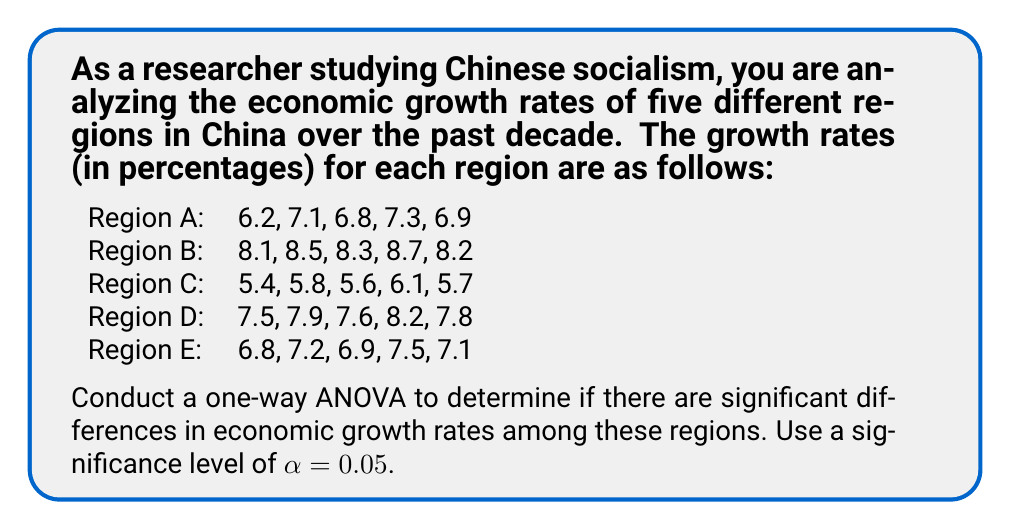Can you answer this question? To conduct a one-way ANOVA, we'll follow these steps:

1. Calculate the sum of squares between groups (SSB), sum of squares within groups (SSW), and total sum of squares (SST).
2. Calculate the degrees of freedom for between groups (dfB) and within groups (dfW).
3. Compute the mean squares between groups (MSB) and within groups (MSW).
4. Calculate the F-statistic.
5. Determine the critical F-value and compare it with our calculated F-statistic.

Step 1: Calculate sums of squares

First, let's calculate the grand mean:
$$ \bar{X} = \frac{6.2 + 7.1 + ... + 7.5 + 7.1}{25} = 7.152 $$

Now, we can calculate SSB, SSW, and SST:

SSB = $\sum_{i=1}^k n_i(\bar{X_i} - \bar{X})^2$
SSW = $\sum_{i=1}^k \sum_{j=1}^{n_i} (X_{ij} - \bar{X_i})^2$
SST = $\sum_{i=1}^k \sum_{j=1}^{n_i} (X_{ij} - \bar{X})^2$

After calculations:
SSB = 30.4416
SSW = 1.616
SST = 32.0576

Step 2: Calculate degrees of freedom

dfB = k - 1 = 5 - 1 = 4 (k is the number of groups)
dfW = N - k = 25 - 5 = 20 (N is the total number of observations)

Step 3: Compute mean squares

MSB = SSB / dfB = 30.4416 / 4 = 7.6104
MSW = SSW / dfW = 1.616 / 20 = 0.0808

Step 4: Calculate F-statistic

F = MSB / MSW = 7.6104 / 0.0808 = 94.1881

Step 5: Determine critical F-value and compare

For α = 0.05, dfB = 4, and dfW = 20, the critical F-value is approximately 2.87 (from F-distribution table).

Since our calculated F-statistic (94.1881) is greater than the critical F-value (2.87), we reject the null hypothesis.
Answer: F(4, 20) = 94.1881, p < 0.05

There is strong evidence to suggest that there are significant differences in economic growth rates among the five regions of China. 